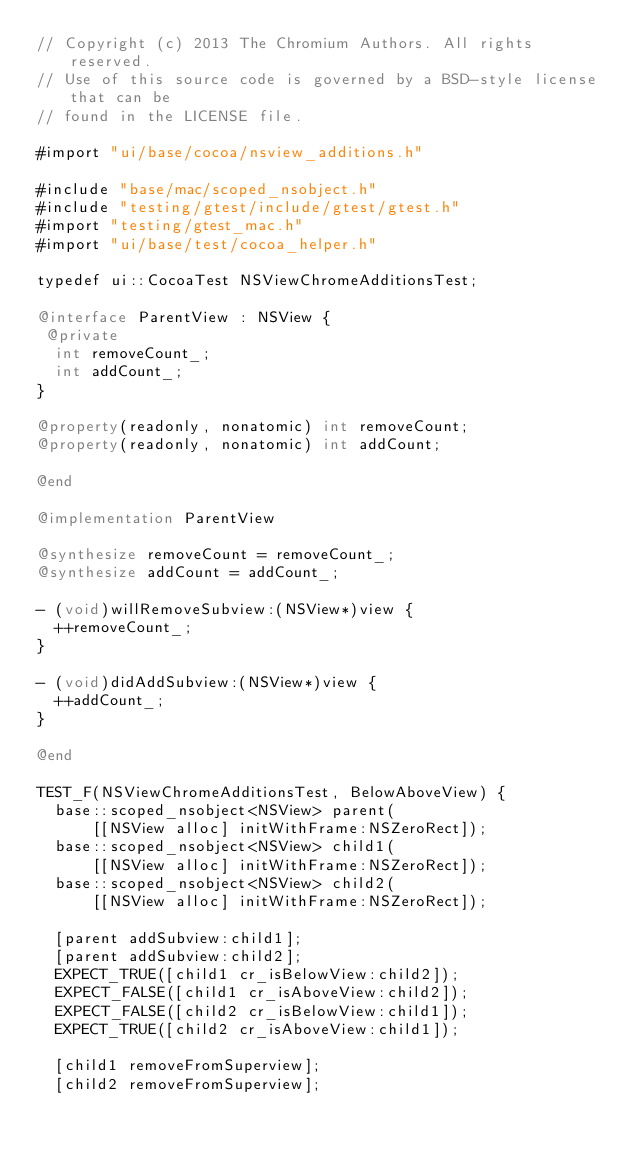<code> <loc_0><loc_0><loc_500><loc_500><_ObjectiveC_>// Copyright (c) 2013 The Chromium Authors. All rights reserved.
// Use of this source code is governed by a BSD-style license that can be
// found in the LICENSE file.

#import "ui/base/cocoa/nsview_additions.h"

#include "base/mac/scoped_nsobject.h"
#include "testing/gtest/include/gtest/gtest.h"
#import "testing/gtest_mac.h"
#import "ui/base/test/cocoa_helper.h"

typedef ui::CocoaTest NSViewChromeAdditionsTest;

@interface ParentView : NSView {
 @private
  int removeCount_;
  int addCount_;
}

@property(readonly, nonatomic) int removeCount;
@property(readonly, nonatomic) int addCount;

@end

@implementation ParentView

@synthesize removeCount = removeCount_;
@synthesize addCount = addCount_;

- (void)willRemoveSubview:(NSView*)view {
  ++removeCount_;
}

- (void)didAddSubview:(NSView*)view {
  ++addCount_;
}

@end

TEST_F(NSViewChromeAdditionsTest, BelowAboveView) {
  base::scoped_nsobject<NSView> parent(
      [[NSView alloc] initWithFrame:NSZeroRect]);
  base::scoped_nsobject<NSView> child1(
      [[NSView alloc] initWithFrame:NSZeroRect]);
  base::scoped_nsobject<NSView> child2(
      [[NSView alloc] initWithFrame:NSZeroRect]);

  [parent addSubview:child1];
  [parent addSubview:child2];
  EXPECT_TRUE([child1 cr_isBelowView:child2]);
  EXPECT_FALSE([child1 cr_isAboveView:child2]);
  EXPECT_FALSE([child2 cr_isBelowView:child1]);
  EXPECT_TRUE([child2 cr_isAboveView:child1]);

  [child1 removeFromSuperview];
  [child2 removeFromSuperview];</code> 